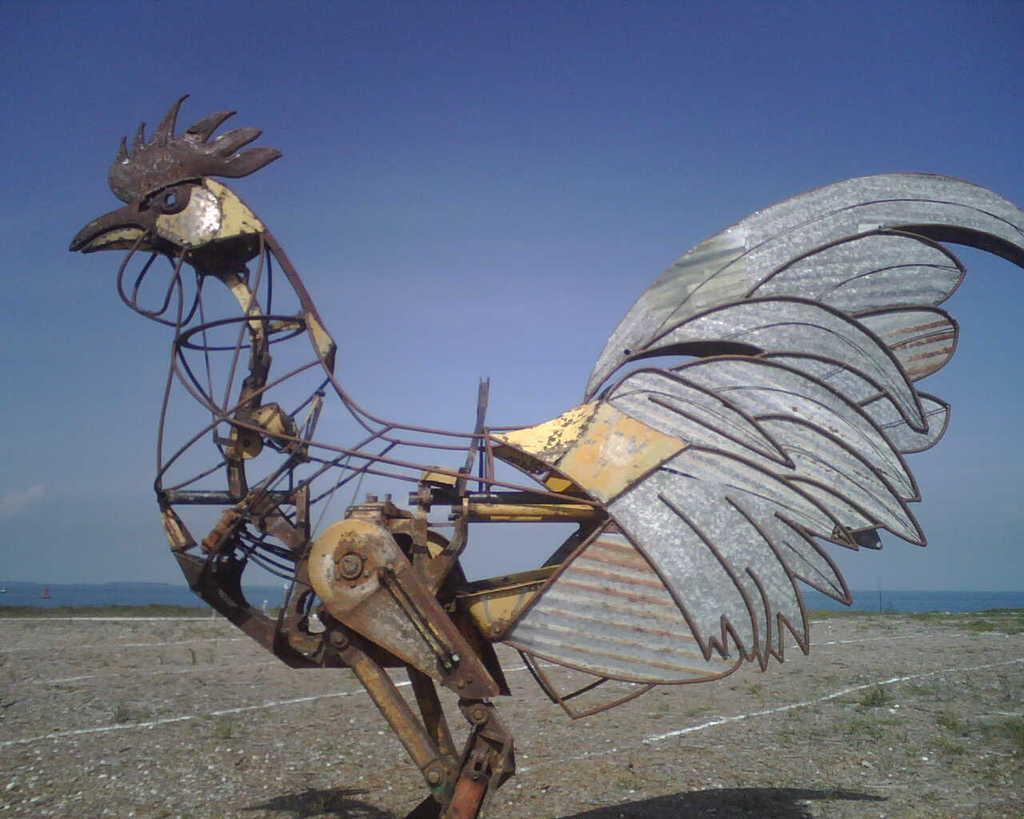Can you describe this image briefly? In the image we can see the hen constructed with metal blocks. Here we can see the grass and the sky. 